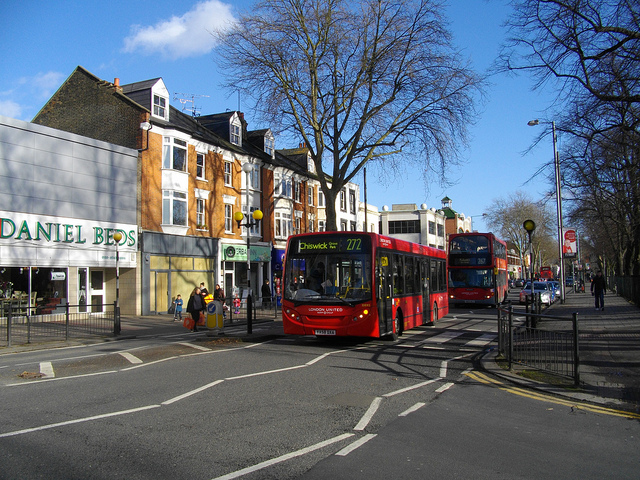Read all the text in this image. DANIEL BEDS 272 